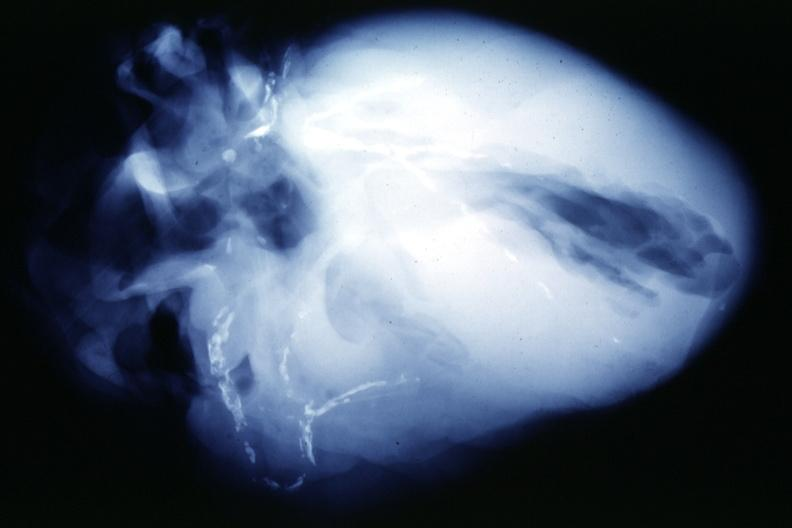where is this from?
Answer the question using a single word or phrase. Vasculature 